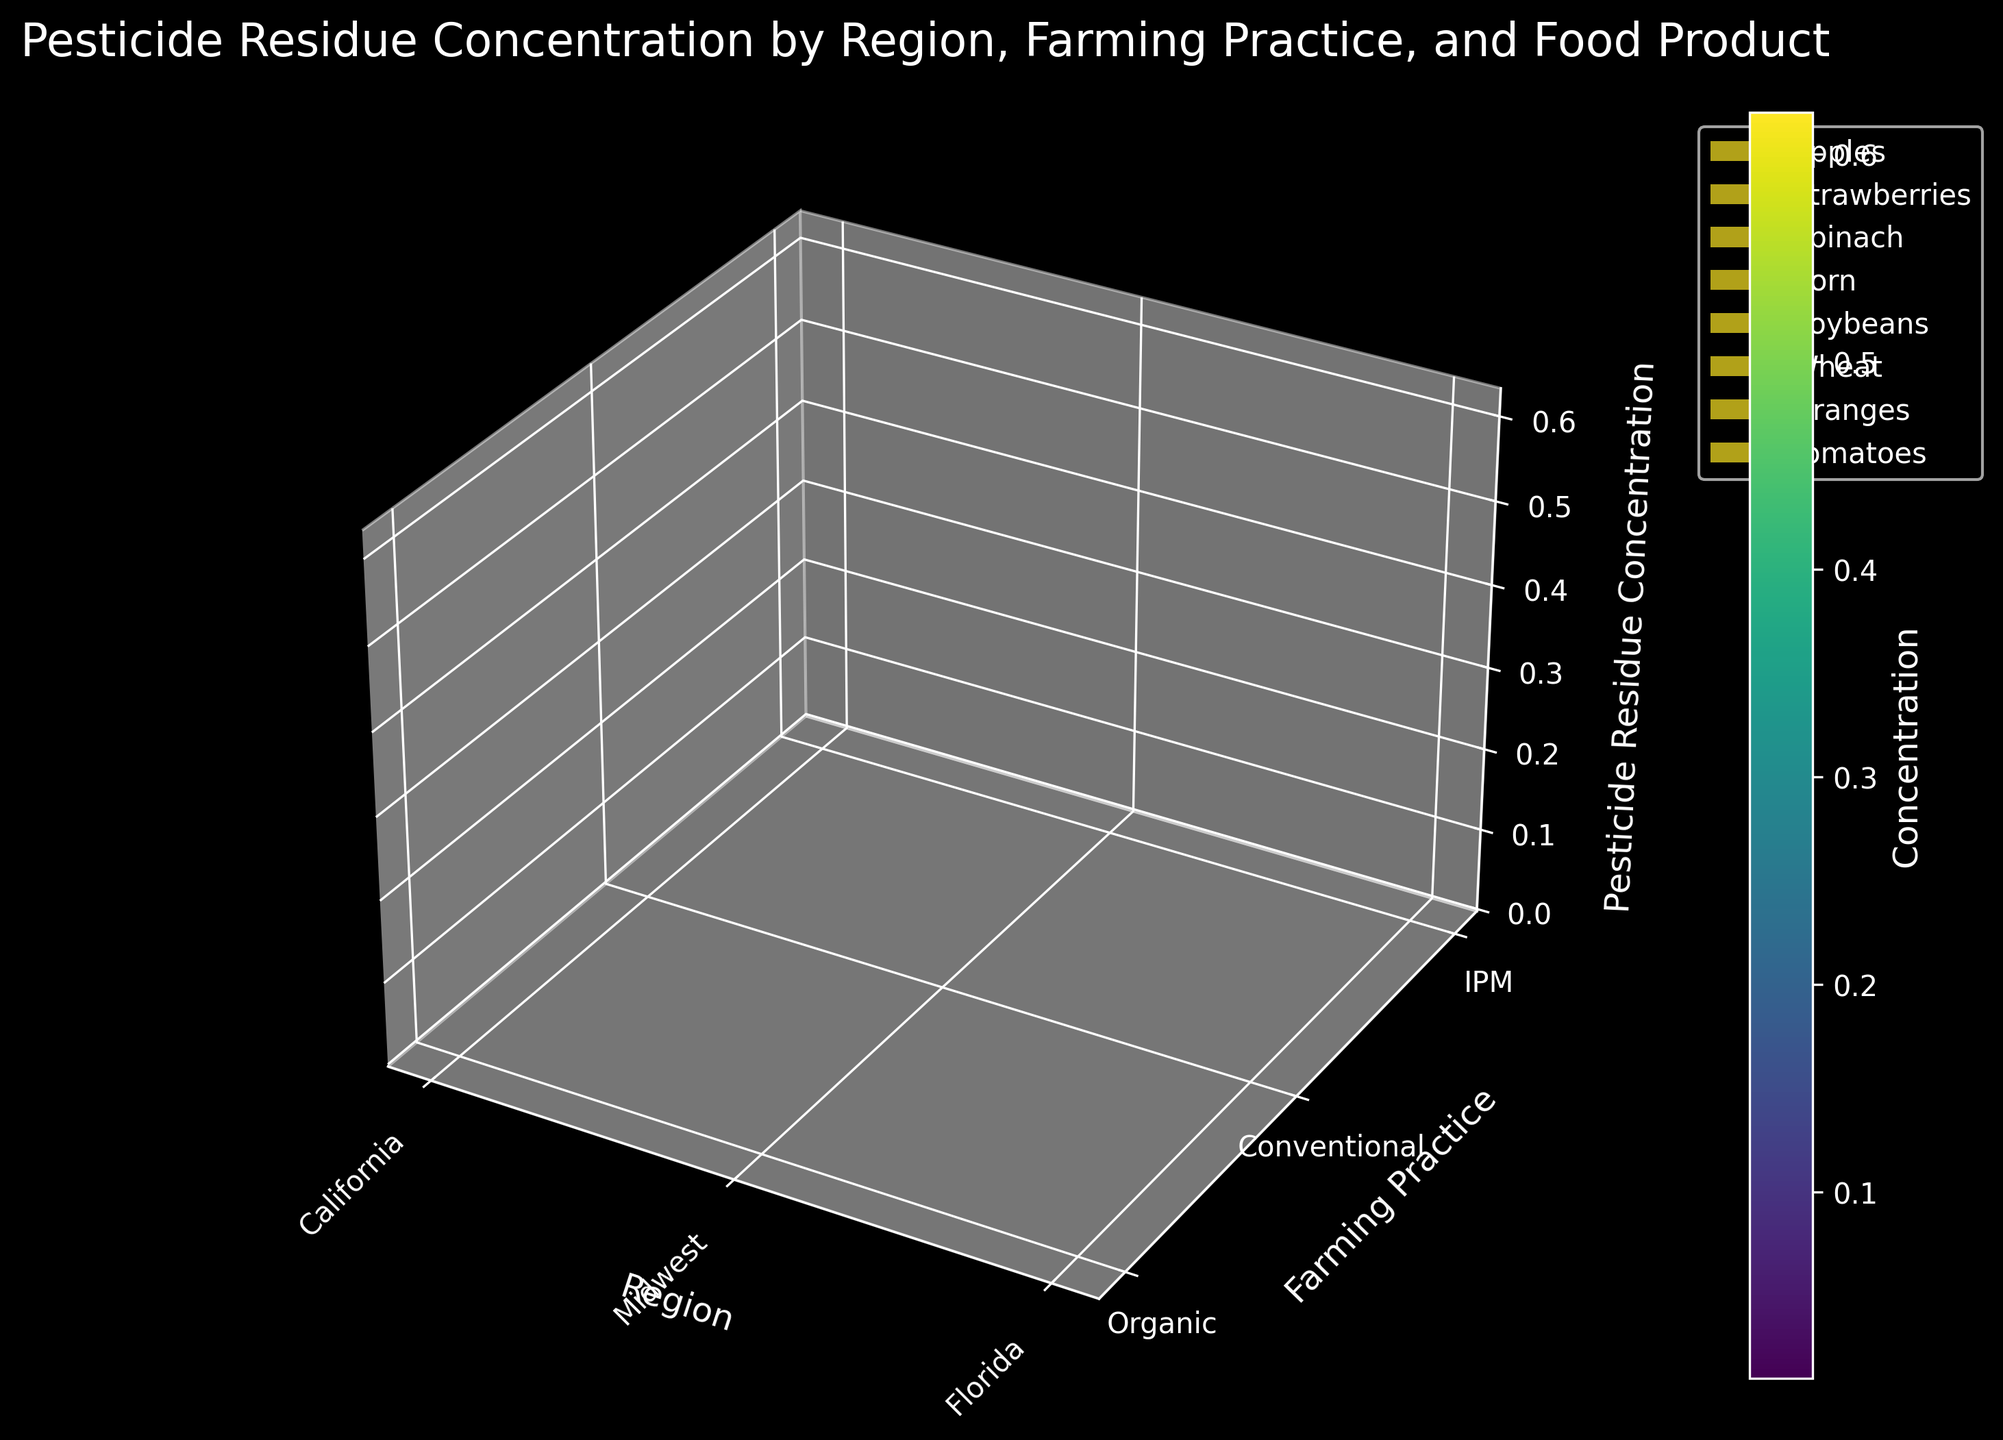What is the title of the figure? The title of a figure is usually shown on top of the plot. Looking at the central part of the plot above the graphics, we can see the text.
Answer: "Pesticide Residue Concentration by Region, Farming Practice, and Food Product" Which region has the highest pesticide residue concentration for strawberries under conventional farming? We need to locate the strawberries surface under conventional farming. Observing the z-axis values and corresponding region (x-axis), the highest peak concentration will help us identify the corresponding region.
Answer: California How does the pesticide residue concentration for apples differ between organic and conventional farming in Florida? By identifying the surfaces representing apples, we'll note down the z-axis values for organic and conventional farming practices. Subtract the value of organic from conventional.
Answer: 0.31 (conventional: 0.35, organic: 0.04) Which farming practice generally shows the lowest pesticide residue concentration across all regions? We compare the surfaces across all regions and inspect the z-axis values for each farming practice. The practice with the consistently lowest z-values is our answer.
Answer: Organic Compare the pesticide residue concentration of oranges between California and Florida for IPM farming practice. Locate the surfaces for oranges under IPM farming. Check the z-values for California and Florida regions and compare them directly.
Answer: Florida: 0.17, California: 0.22 What is the average pesticide residue concentration for soybeans across all regions under conventional farming? Identify the soybeans surfaces under conventional farming. Extract the z-values for each region (Midwest and California) and calculate the average.
Answer: (0.22 + 0.28) / 2 = 0.25 Which food product shows the largest variation in pesticide residue concentration across different regions under conventional farming practices? Look at the spread and range in z-values for each food product surface under conventional practice. The product showing the largest range values indicates the highest variation.
Answer: Strawberries If pesticide residue concentration in spinach under conventional farming in California is removed, how does it affect the overall appearance of the surface plot? Removing the specific data point leads to a gap in the spinach surface for conventional farming in the California region, affecting its continuity and smoothness.
Answer: It creates a gap in the surface continuity 